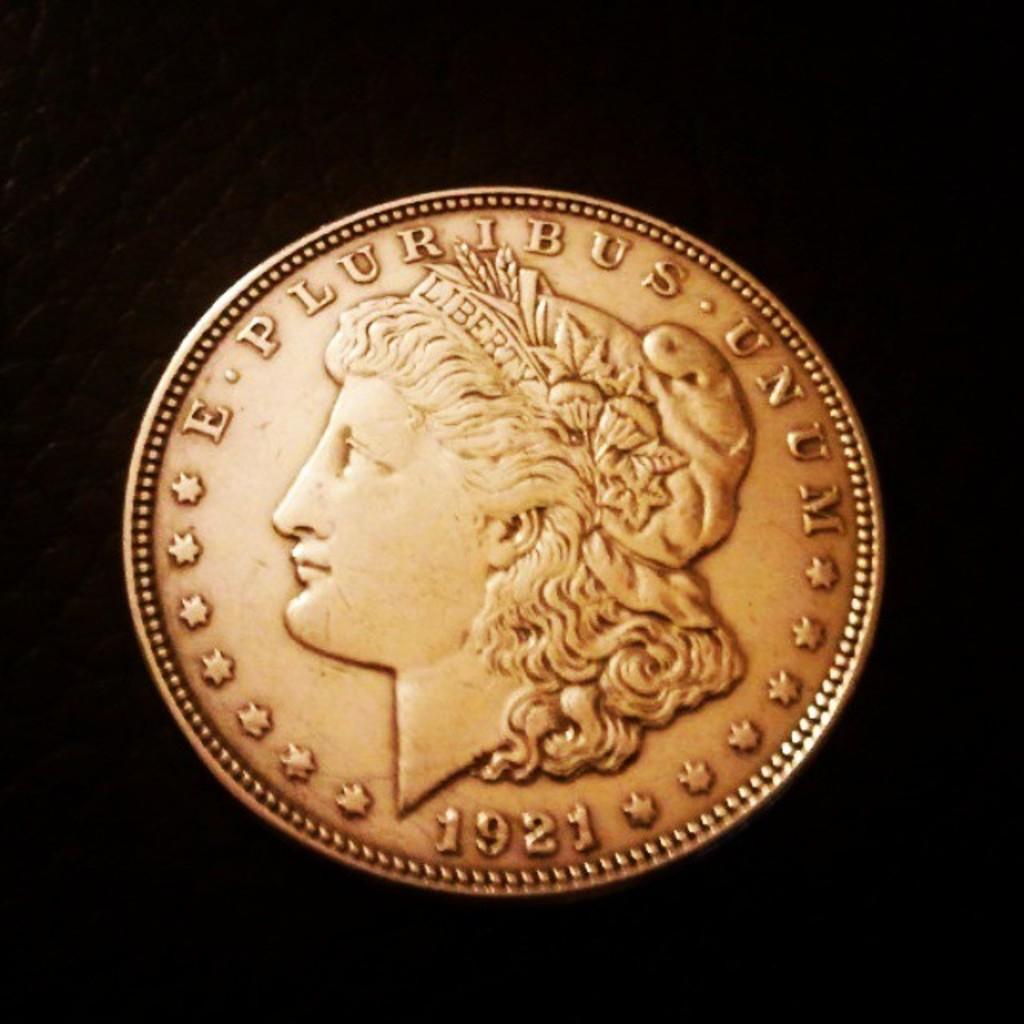What year is this coin from?
Your response must be concise. 1921. What is the phrase on this coin?
Give a very brief answer. E pluribus unum. 